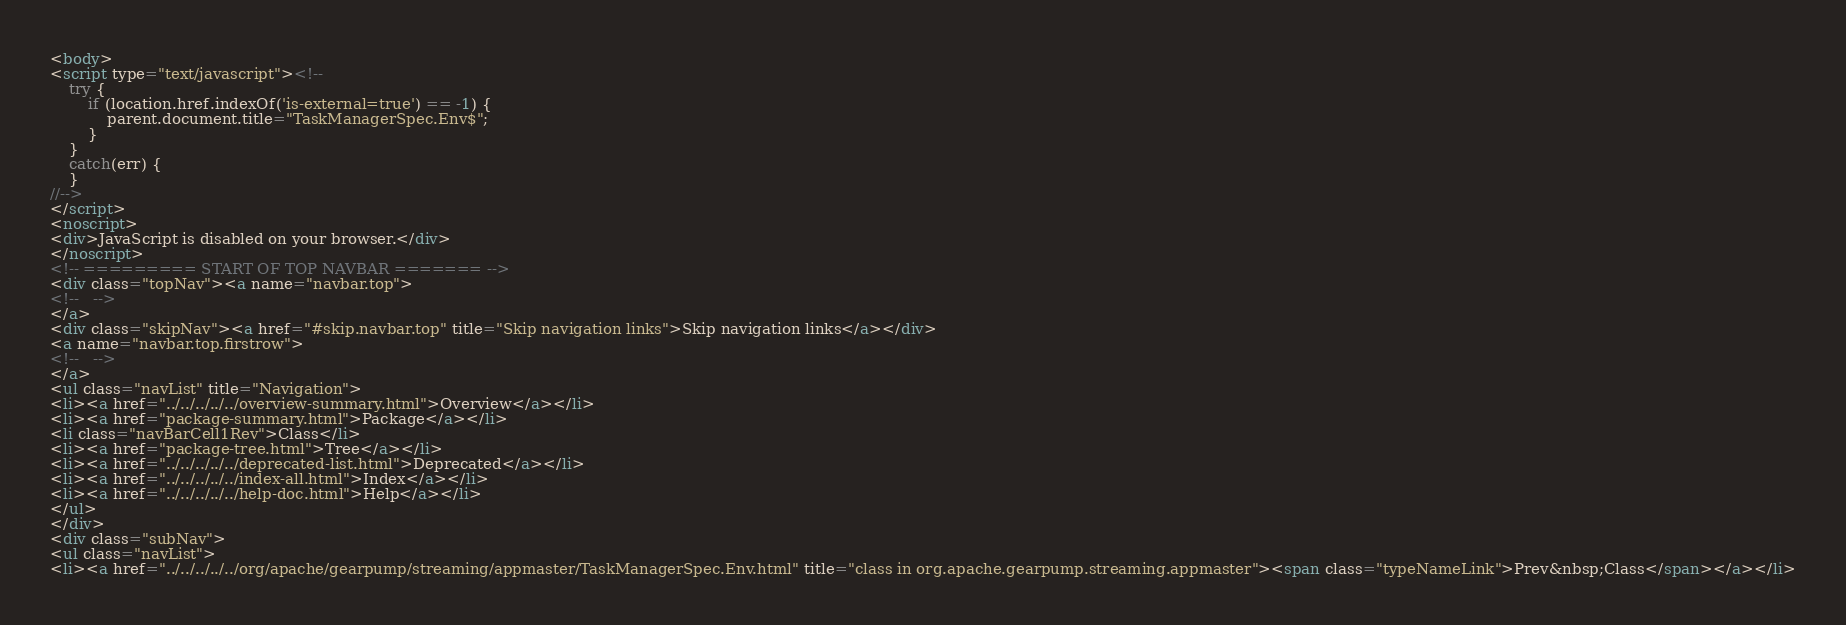Convert code to text. <code><loc_0><loc_0><loc_500><loc_500><_HTML_><body>
<script type="text/javascript"><!--
    try {
        if (location.href.indexOf('is-external=true') == -1) {
            parent.document.title="TaskManagerSpec.Env$";
        }
    }
    catch(err) {
    }
//-->
</script>
<noscript>
<div>JavaScript is disabled on your browser.</div>
</noscript>
<!-- ========= START OF TOP NAVBAR ======= -->
<div class="topNav"><a name="navbar.top">
<!--   -->
</a>
<div class="skipNav"><a href="#skip.navbar.top" title="Skip navigation links">Skip navigation links</a></div>
<a name="navbar.top.firstrow">
<!--   -->
</a>
<ul class="navList" title="Navigation">
<li><a href="../../../../../overview-summary.html">Overview</a></li>
<li><a href="package-summary.html">Package</a></li>
<li class="navBarCell1Rev">Class</li>
<li><a href="package-tree.html">Tree</a></li>
<li><a href="../../../../../deprecated-list.html">Deprecated</a></li>
<li><a href="../../../../../index-all.html">Index</a></li>
<li><a href="../../../../../help-doc.html">Help</a></li>
</ul>
</div>
<div class="subNav">
<ul class="navList">
<li><a href="../../../../../org/apache/gearpump/streaming/appmaster/TaskManagerSpec.Env.html" title="class in org.apache.gearpump.streaming.appmaster"><span class="typeNameLink">Prev&nbsp;Class</span></a></li></code> 